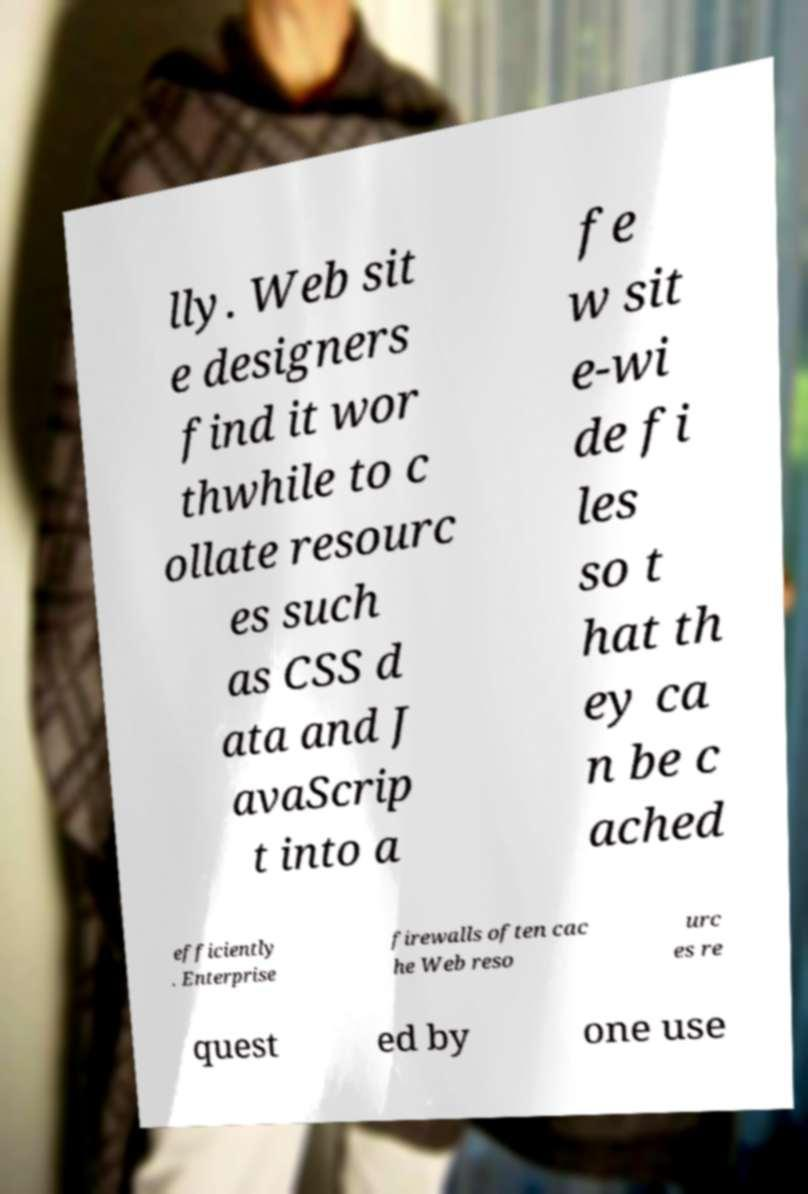I need the written content from this picture converted into text. Can you do that? lly. Web sit e designers find it wor thwhile to c ollate resourc es such as CSS d ata and J avaScrip t into a fe w sit e-wi de fi les so t hat th ey ca n be c ached efficiently . Enterprise firewalls often cac he Web reso urc es re quest ed by one use 